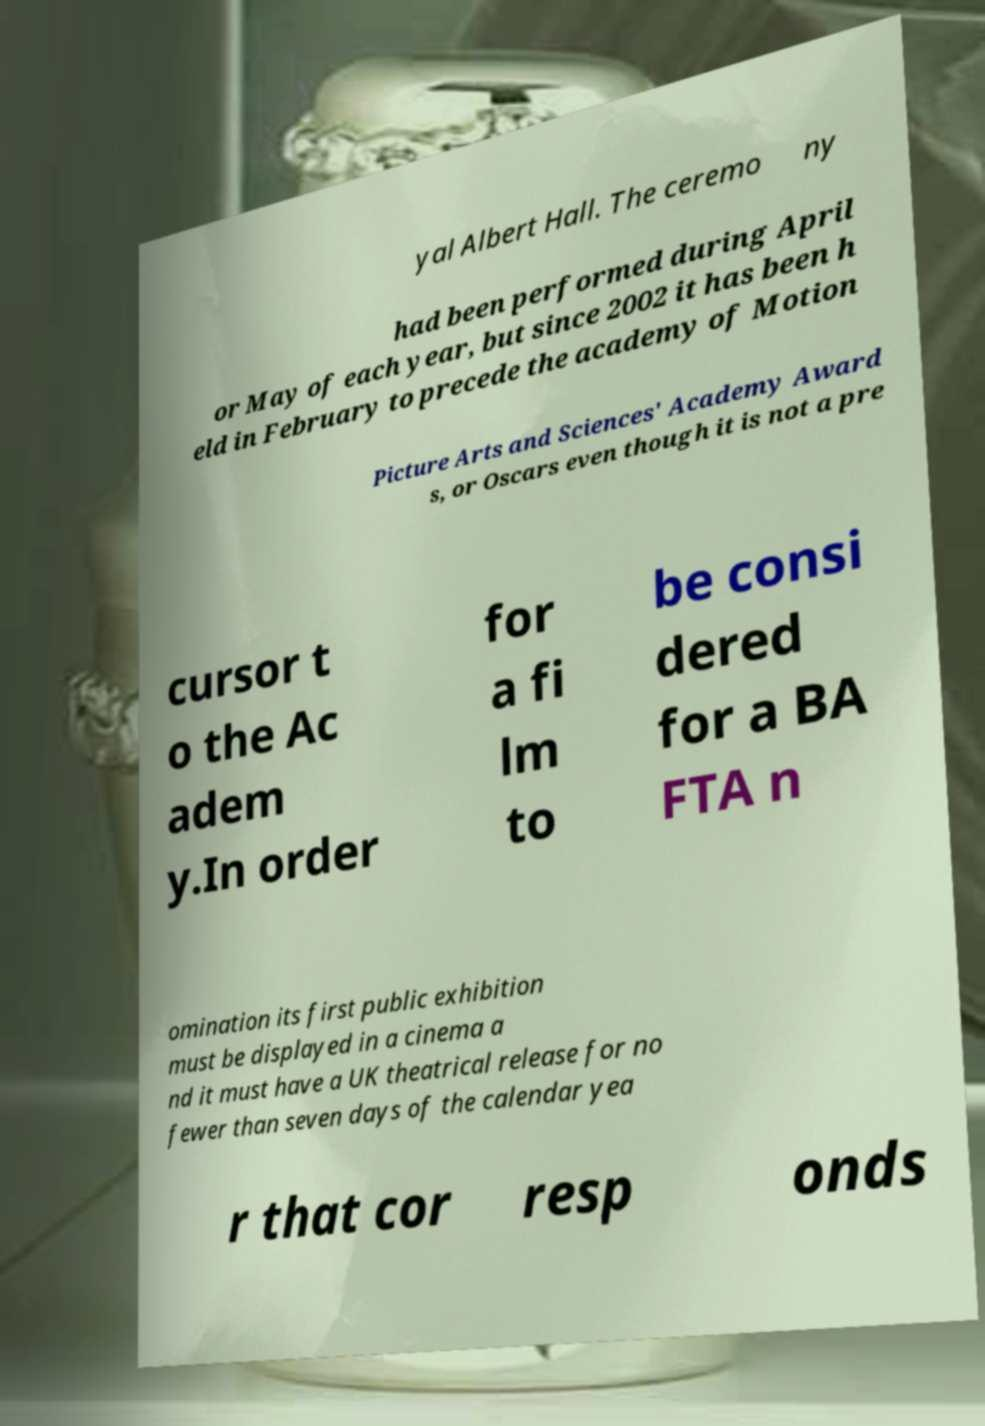Could you assist in decoding the text presented in this image and type it out clearly? yal Albert Hall. The ceremo ny had been performed during April or May of each year, but since 2002 it has been h eld in February to precede the academy of Motion Picture Arts and Sciences' Academy Award s, or Oscars even though it is not a pre cursor t o the Ac adem y.In order for a fi lm to be consi dered for a BA FTA n omination its first public exhibition must be displayed in a cinema a nd it must have a UK theatrical release for no fewer than seven days of the calendar yea r that cor resp onds 